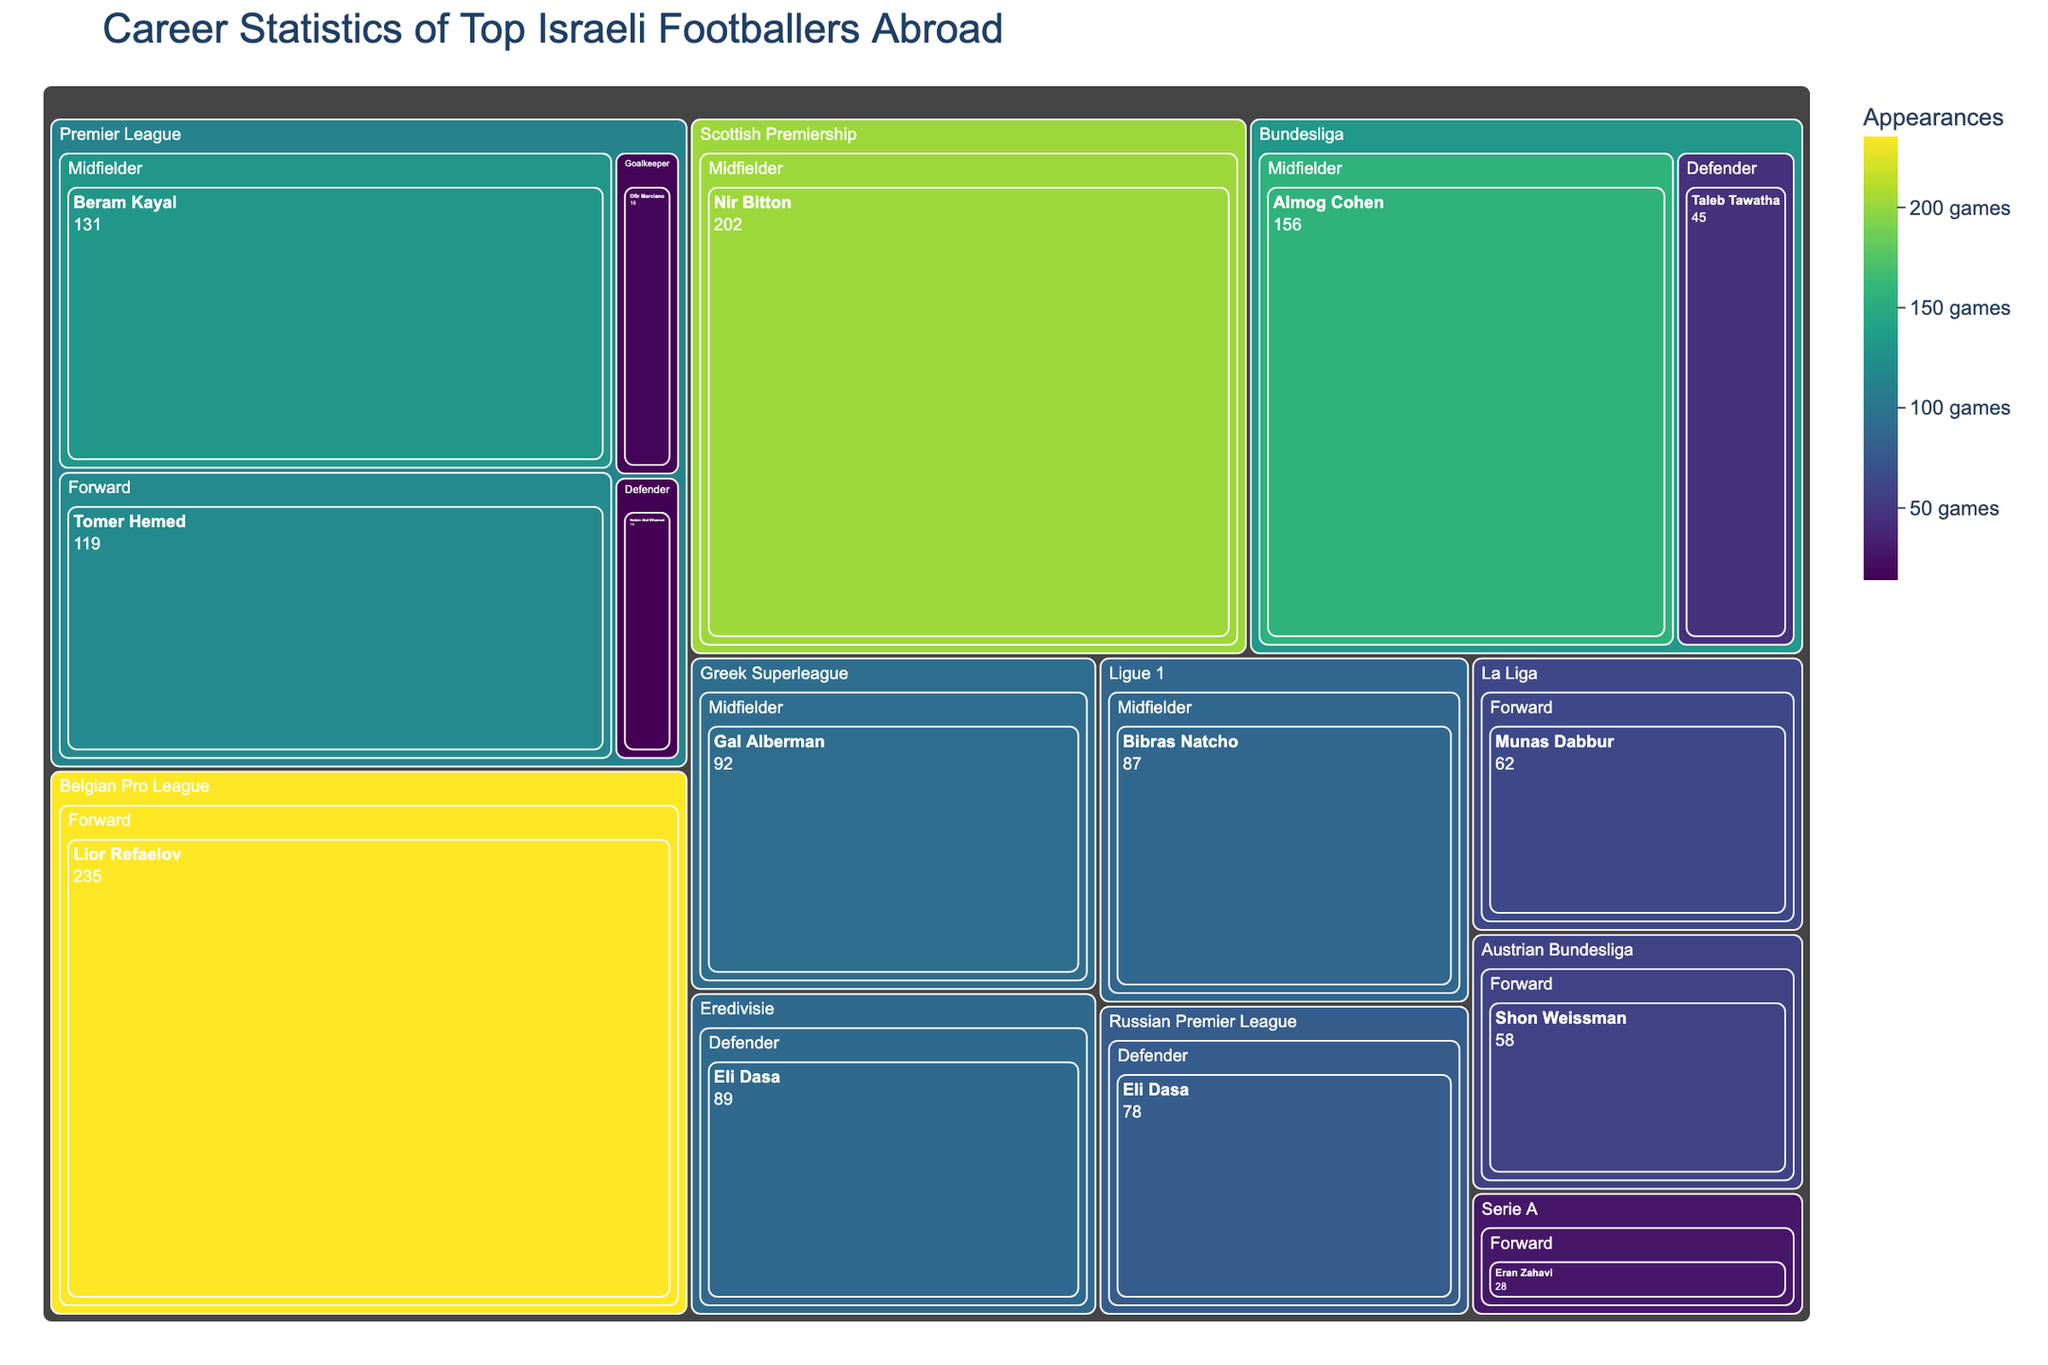Which league has the player with the highest number of appearances? Lior Refaelov in the Belgian Pro League has the highest number of appearances with 235. This can be identified by locating the largest rectangle in the treemap and verifying the number of appearances associated with it.
Answer: Belgian Pro League Who is the footballer with the most appearances as a forward? Lior Refaelov, playing in the Belgian Pro League, has the most appearances as a forward with 235 appearances. By reviewing forward players across all leagues in the treemap, the largest area among them leads to Lior Refaelov.
Answer: Lior Refaelov How many footballers have played in the Premier League? There are four footballers in the Premier League: Tomer Hemed, Beram Kayal, Ofir Marciano, and Hatem Abd Elhamed. This is determined by counting the unique player names under the Premier League category in the treemap.
Answer: Four Which midfielder has the highest number of appearances? Nir Bitton in the Scottish Premiership has the highest number of appearances among midfielders with 202 appearances. This information is found by comparing the areas of rectangles representing midfielders in different leagues and identifying the largest one.
Answer: Nir Bitton What's the total number of appearances made by defenders? The total number of appearances made by defenders is calculated by summing the appearances of Taleb Tawatha (45), Eli Dasa (89), Eli Dasa (78), and Hatem Abd Elhamed (14). So, 45 + 89 + 78 + 14 = 226
Answer: 226 How does the appearance count of Eran Zahavi in Serie A compare to that of Munas Dabbur in La Liga? Eran Zahavi in Serie A has made 28 appearances, whereas Munas Dabbur in La Liga has made 62 appearances. Comparing the numbers, Munas Dabbur has more appearances.
Answer: Munas Dabbur has more What is the average number of appearances made by goalkeepers? Ofir Marciano in the Premier League is the only goalkeeper listed, with 16 appearances. The average is the total appearances (16) divided by the number of goalkeepers (1), so 16 / 1 = 16
Answer: 16 Which league has the highest average number of appearances among its players? To find the league with the highest average number of appearances: 
1. Calculate the total and average for each league.
   - Premier League: (119 + 131 + 16 + 14) / 4 = 280 / 4 = 70
   - Bundesliga: (45 + 156) / 2 = 201 / 2 = 100.5
   - Serie A: 28 / 1 = 28
   - Ligue 1: 87 / 1 = 87
   - La Liga: 62 / 1 = 62
   - Eredivisie: 89 / 1 = 89
   - Scottish Premiership: 202 / 1 = 202
   - Belgian Pro League: 235 / 1 = 235
   - Russian Premier League: 78 / 1 = 78
   - Austrian Bundesliga: 58 / 1 = 58
   - Greek Superleague: 92 / 1 = 92 
Upon comparison, the Belgian Pro League has the highest average of 235.
Answer: Belgian Pro League 